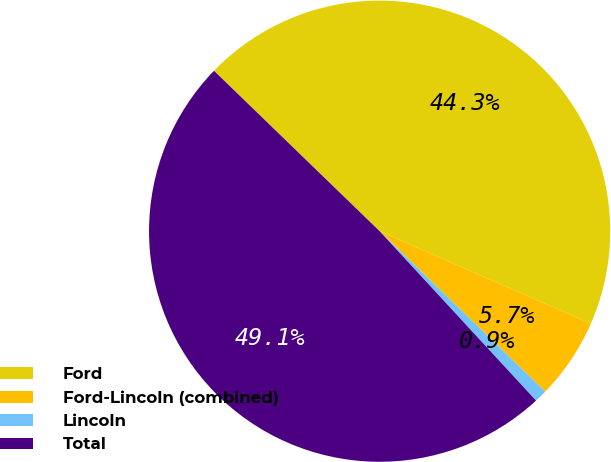Convert chart. <chart><loc_0><loc_0><loc_500><loc_500><pie_chart><fcel>Ford<fcel>Ford-Lincoln (combined)<fcel>Lincoln<fcel>Total<nl><fcel>44.32%<fcel>5.68%<fcel>0.89%<fcel>49.11%<nl></chart> 